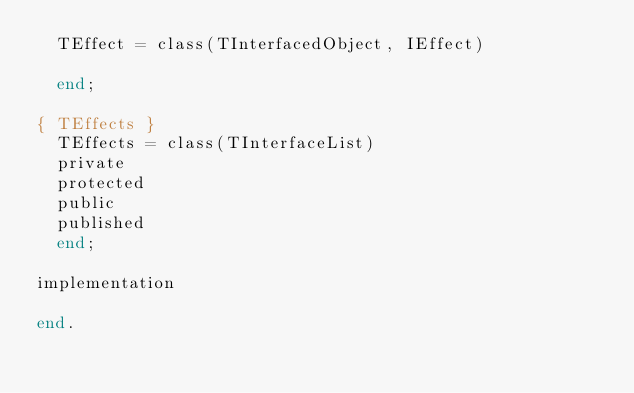Convert code to text. <code><loc_0><loc_0><loc_500><loc_500><_Pascal_>  TEffect = class(TInterfacedObject, IEffect)

  end;

{ TEffects }
  TEffects = class(TInterfaceList)
  private
  protected
  public
  published
  end;

implementation

end.
</code> 